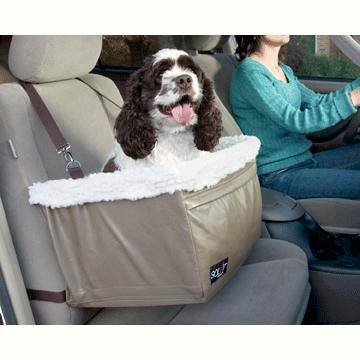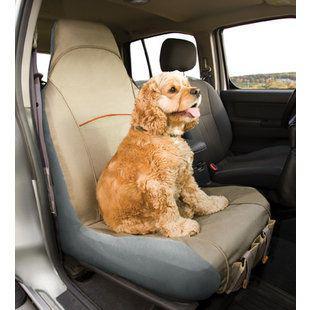The first image is the image on the left, the second image is the image on the right. Assess this claim about the two images: "One dog is riding in a carrier.". Correct or not? Answer yes or no. Yes. The first image is the image on the left, the second image is the image on the right. Analyze the images presented: Is the assertion "Each image shows one spaniel riding in a car, and one image shows a spaniel sitting in a soft-sided box suspended over a seat by seat belts." valid? Answer yes or no. Yes. 